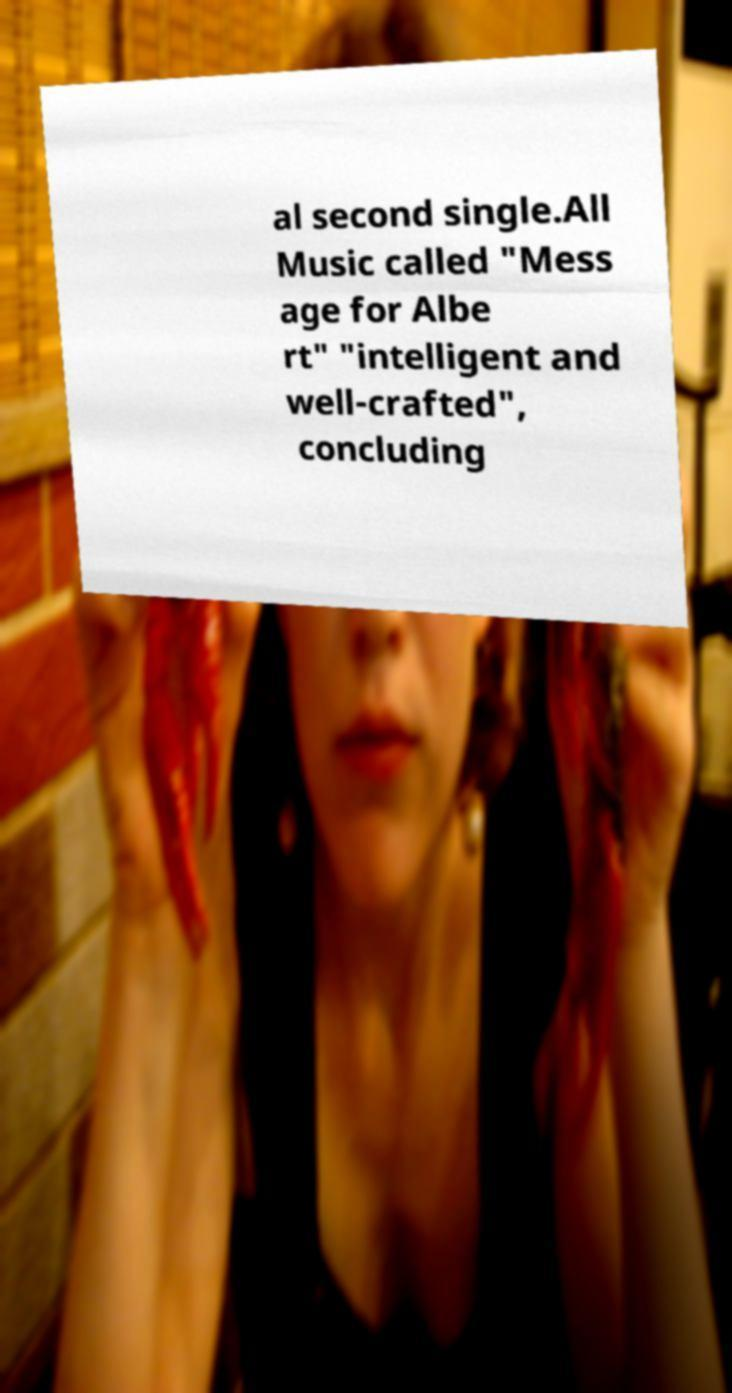Can you accurately transcribe the text from the provided image for me? al second single.All Music called "Mess age for Albe rt" "intelligent and well-crafted", concluding 